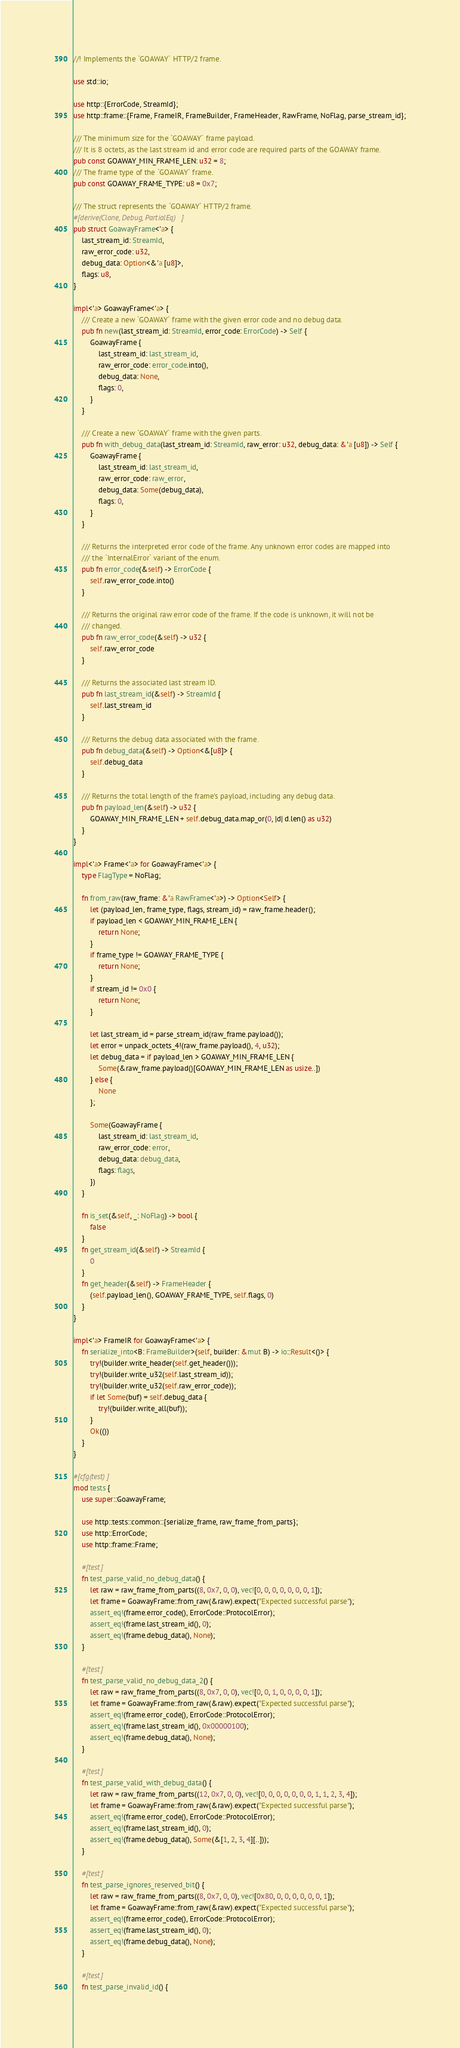<code> <loc_0><loc_0><loc_500><loc_500><_Rust_>//! Implements the `GOAWAY` HTTP/2 frame.

use std::io;

use http::{ErrorCode, StreamId};
use http::frame::{Frame, FrameIR, FrameBuilder, FrameHeader, RawFrame, NoFlag, parse_stream_id};

/// The minimum size for the `GOAWAY` frame payload.
/// It is 8 octets, as the last stream id and error code are required parts of the GOAWAY frame.
pub const GOAWAY_MIN_FRAME_LEN: u32 = 8;
/// The frame type of the `GOAWAY` frame.
pub const GOAWAY_FRAME_TYPE: u8 = 0x7;

/// The struct represents the `GOAWAY` HTTP/2 frame.
#[derive(Clone, Debug, PartialEq)]
pub struct GoawayFrame<'a> {
    last_stream_id: StreamId,
    raw_error_code: u32,
    debug_data: Option<&'a [u8]>,
    flags: u8,
}

impl<'a> GoawayFrame<'a> {
    /// Create a new `GOAWAY` frame with the given error code and no debug data.
    pub fn new(last_stream_id: StreamId, error_code: ErrorCode) -> Self {
        GoawayFrame {
            last_stream_id: last_stream_id,
            raw_error_code: error_code.into(),
            debug_data: None,
            flags: 0,
        }
    }

    /// Create a new `GOAWAY` frame with the given parts.
    pub fn with_debug_data(last_stream_id: StreamId, raw_error: u32, debug_data: &'a [u8]) -> Self {
        GoawayFrame {
            last_stream_id: last_stream_id,
            raw_error_code: raw_error,
            debug_data: Some(debug_data),
            flags: 0,
        }
    }

    /// Returns the interpreted error code of the frame. Any unknown error codes are mapped into
    /// the `InternalError` variant of the enum.
    pub fn error_code(&self) -> ErrorCode {
        self.raw_error_code.into()
    }

    /// Returns the original raw error code of the frame. If the code is unknown, it will not be
    /// changed.
    pub fn raw_error_code(&self) -> u32 {
        self.raw_error_code
    }

    /// Returns the associated last stream ID.
    pub fn last_stream_id(&self) -> StreamId {
        self.last_stream_id
    }

    /// Returns the debug data associated with the frame.
    pub fn debug_data(&self) -> Option<&[u8]> {
        self.debug_data
    }

    /// Returns the total length of the frame's payload, including any debug data.
    pub fn payload_len(&self) -> u32 {
        GOAWAY_MIN_FRAME_LEN + self.debug_data.map_or(0, |d| d.len() as u32)
    }
}

impl<'a> Frame<'a> for GoawayFrame<'a> {
    type FlagType = NoFlag;

    fn from_raw(raw_frame: &'a RawFrame<'a>) -> Option<Self> {
        let (payload_len, frame_type, flags, stream_id) = raw_frame.header();
        if payload_len < GOAWAY_MIN_FRAME_LEN {
            return None;
        }
        if frame_type != GOAWAY_FRAME_TYPE {
            return None;
        }
        if stream_id != 0x0 {
            return None;
        }

        let last_stream_id = parse_stream_id(raw_frame.payload());
        let error = unpack_octets_4!(raw_frame.payload(), 4, u32);
        let debug_data = if payload_len > GOAWAY_MIN_FRAME_LEN {
            Some(&raw_frame.payload()[GOAWAY_MIN_FRAME_LEN as usize..])
        } else {
            None
        };

        Some(GoawayFrame {
            last_stream_id: last_stream_id,
            raw_error_code: error,
            debug_data: debug_data,
            flags: flags,
        })
    }

    fn is_set(&self, _: NoFlag) -> bool {
        false
    }
    fn get_stream_id(&self) -> StreamId {
        0
    }
    fn get_header(&self) -> FrameHeader {
        (self.payload_len(), GOAWAY_FRAME_TYPE, self.flags, 0)
    }
}

impl<'a> FrameIR for GoawayFrame<'a> {
    fn serialize_into<B: FrameBuilder>(self, builder: &mut B) -> io::Result<()> {
        try!(builder.write_header(self.get_header()));
        try!(builder.write_u32(self.last_stream_id));
        try!(builder.write_u32(self.raw_error_code));
        if let Some(buf) = self.debug_data {
            try!(builder.write_all(buf));
        }
        Ok(())
    }
}

#[cfg(test)]
mod tests {
    use super::GoawayFrame;

    use http::tests::common::{serialize_frame, raw_frame_from_parts};
    use http::ErrorCode;
    use http::frame::Frame;

    #[test]
    fn test_parse_valid_no_debug_data() {
        let raw = raw_frame_from_parts((8, 0x7, 0, 0), vec![0, 0, 0, 0, 0, 0, 0, 1]);
        let frame = GoawayFrame::from_raw(&raw).expect("Expected successful parse");
        assert_eq!(frame.error_code(), ErrorCode::ProtocolError);
        assert_eq!(frame.last_stream_id(), 0);
        assert_eq!(frame.debug_data(), None);
    }

    #[test]
    fn test_parse_valid_no_debug_data_2() {
        let raw = raw_frame_from_parts((8, 0x7, 0, 0), vec![0, 0, 1, 0, 0, 0, 0, 1]);
        let frame = GoawayFrame::from_raw(&raw).expect("Expected successful parse");
        assert_eq!(frame.error_code(), ErrorCode::ProtocolError);
        assert_eq!(frame.last_stream_id(), 0x00000100);
        assert_eq!(frame.debug_data(), None);
    }

    #[test]
    fn test_parse_valid_with_debug_data() {
        let raw = raw_frame_from_parts((12, 0x7, 0, 0), vec![0, 0, 0, 0, 0, 0, 0, 1, 1, 2, 3, 4]);
        let frame = GoawayFrame::from_raw(&raw).expect("Expected successful parse");
        assert_eq!(frame.error_code(), ErrorCode::ProtocolError);
        assert_eq!(frame.last_stream_id(), 0);
        assert_eq!(frame.debug_data(), Some(&[1, 2, 3, 4][..]));
    }

    #[test]
    fn test_parse_ignores_reserved_bit() {
        let raw = raw_frame_from_parts((8, 0x7, 0, 0), vec![0x80, 0, 0, 0, 0, 0, 0, 1]);
        let frame = GoawayFrame::from_raw(&raw).expect("Expected successful parse");
        assert_eq!(frame.error_code(), ErrorCode::ProtocolError);
        assert_eq!(frame.last_stream_id(), 0);
        assert_eq!(frame.debug_data(), None);
    }

    #[test]
    fn test_parse_invalid_id() {</code> 